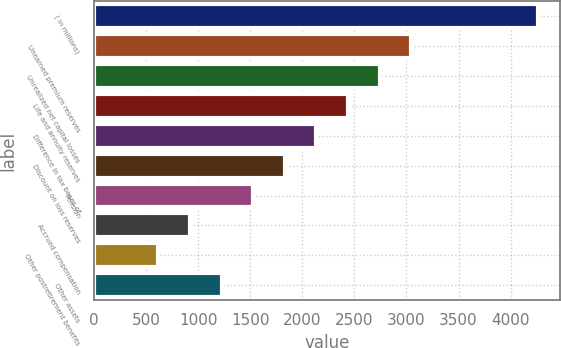Convert chart to OTSL. <chart><loc_0><loc_0><loc_500><loc_500><bar_chart><fcel>( in millions)<fcel>Unearned premium reserves<fcel>Unrealized net capital losses<fcel>Life and annuity reserves<fcel>Difference in tax bases of<fcel>Discount on loss reserves<fcel>Pension<fcel>Accrued compensation<fcel>Other postretirement benefits<fcel>Other assets<nl><fcel>4258.6<fcel>3045<fcel>2741.6<fcel>2438.2<fcel>2134.8<fcel>1831.4<fcel>1528<fcel>921.2<fcel>617.8<fcel>1224.6<nl></chart> 